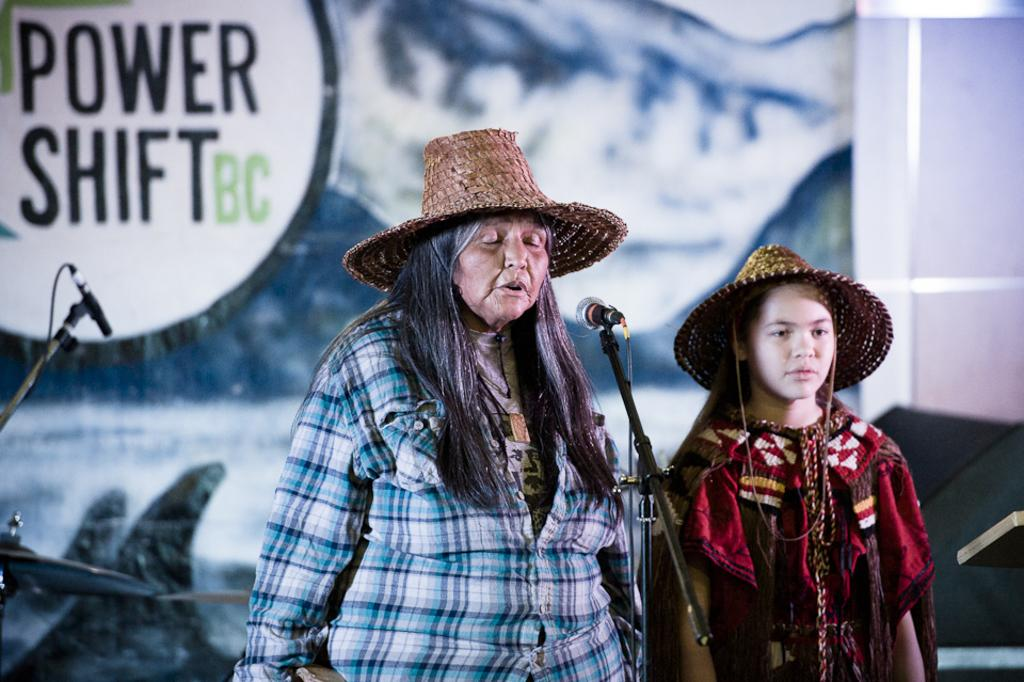What is happening in the image? There are persons standing in the image. What object is in the front of the image? There is a microphone (mic) in the front of the image. What can be seen in the background of the image? There is a banner with text and a mic stand in the background of the image. How much wealth is displayed in the image? There is no indication of wealth in the image; it features persons standing with a microphone, banner, and mic stand. What type of body is visible in the image? There is no specific body visible in the image; it shows persons standing and objects like a microphone, banner, and mic stand. 